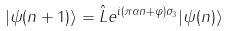<formula> <loc_0><loc_0><loc_500><loc_500>| \psi ( n + 1 ) \rangle = \hat { L } e ^ { i ( \pi \alpha n + \varphi ) \sigma _ { 3 } } | \psi ( n ) \rangle \,</formula> 